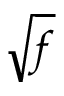Convert formula to latex. <formula><loc_0><loc_0><loc_500><loc_500>\sqrt { f }</formula> 